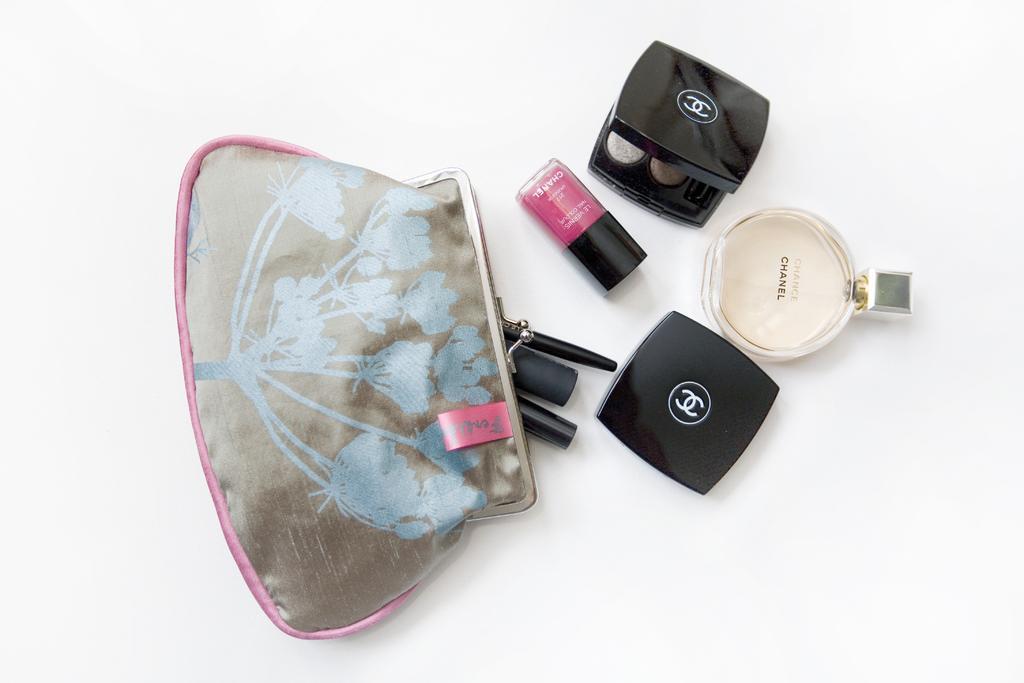Could you give a brief overview of what you see in this image? There is a perfume bottle, black color boxes, nail polish and a pouch with some items are on a white surface. 